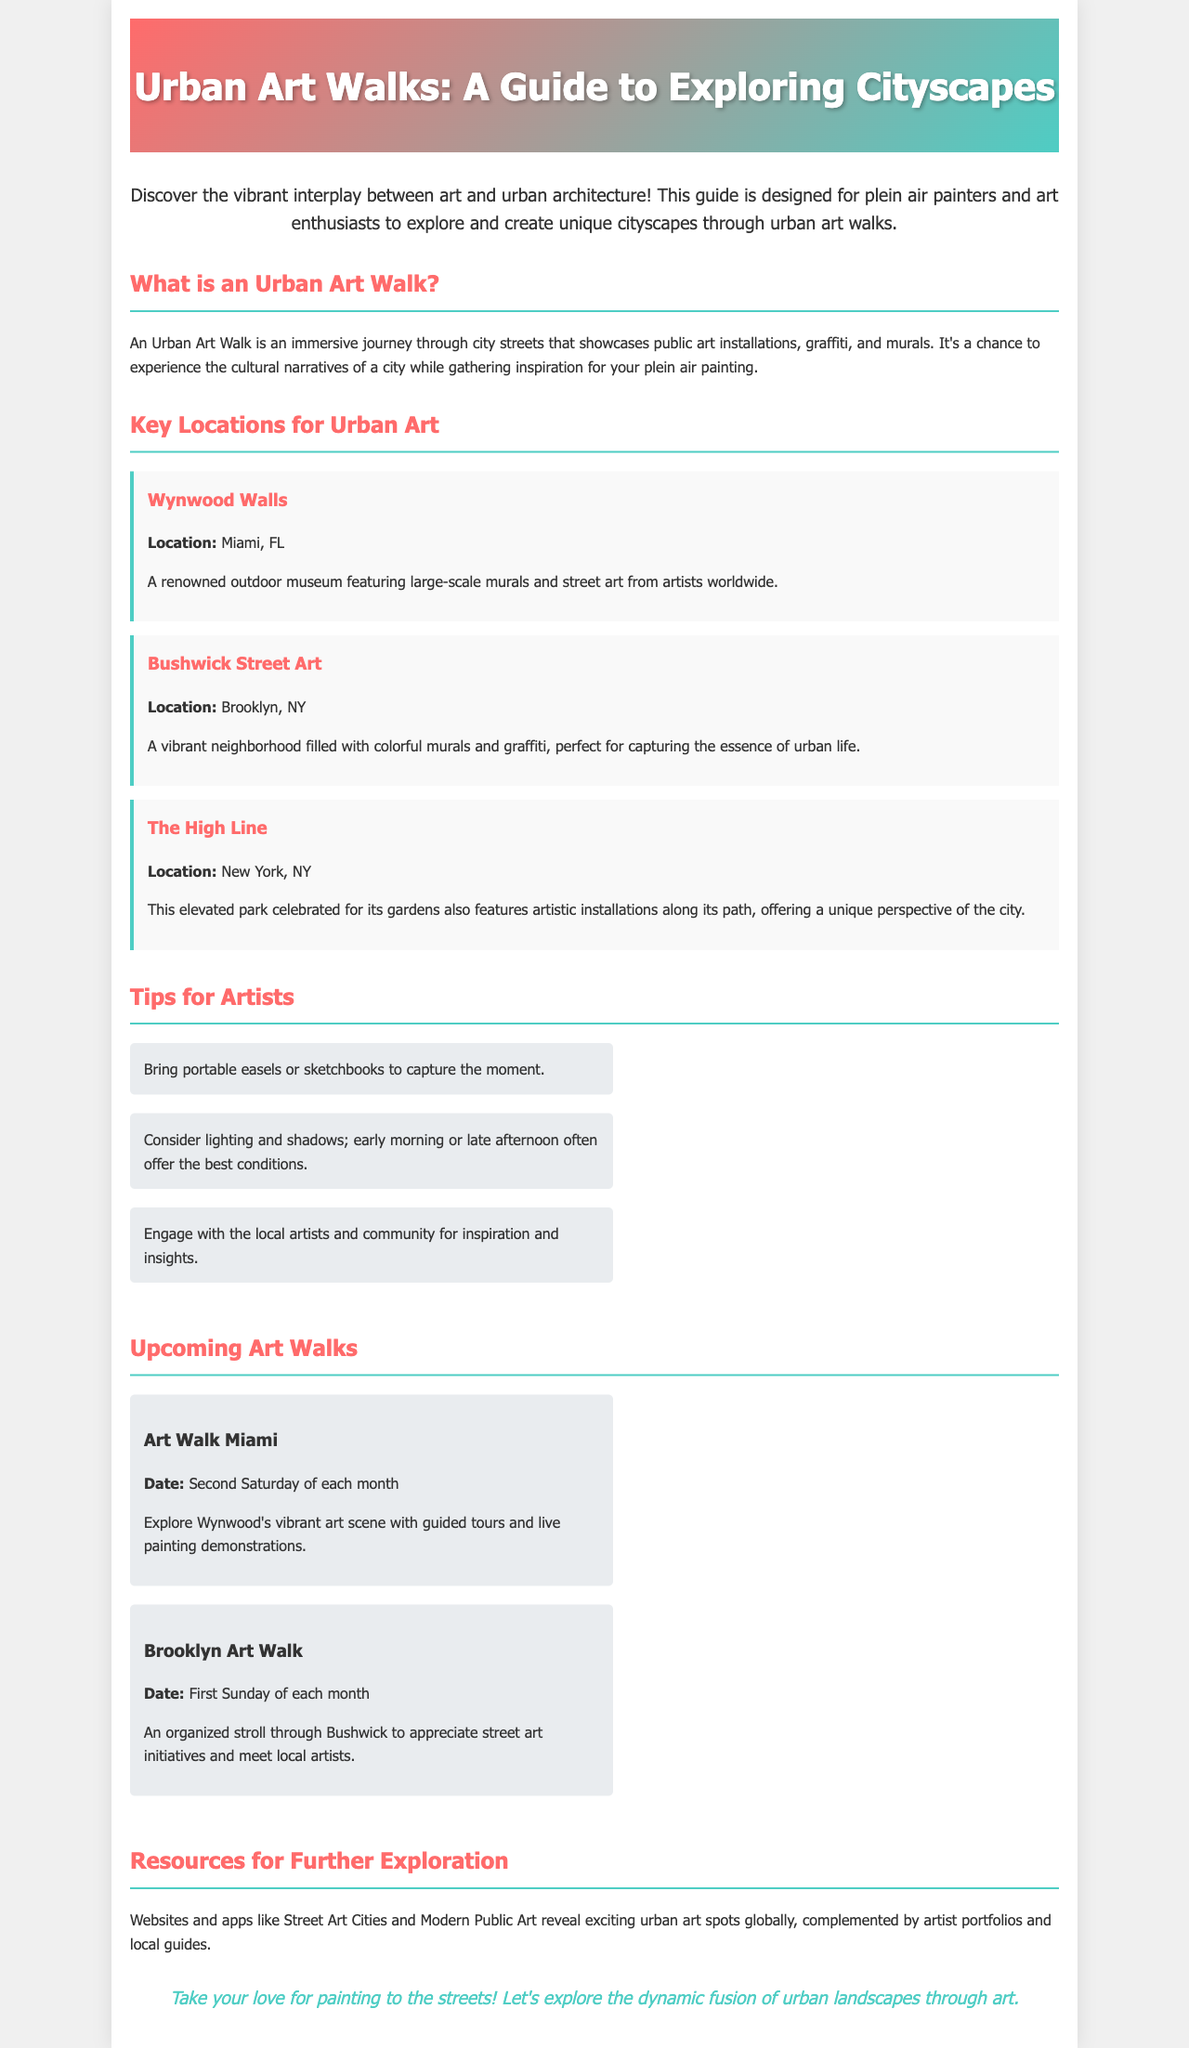What is an Urban Art Walk? An Urban Art Walk is defined in the brochure as an immersive journey through city streets that showcases public art installations, graffiti, and murals.
Answer: An immersive journey through city streets What is the location of Wynwood Walls? The brochure specifies that Wynwood Walls is located in Miami, FL.
Answer: Miami, FL When does the Brooklyn Art Walk occur? The document states that the Brooklyn Art Walk takes place on the first Sunday of each month.
Answer: First Sunday of each month What is a tip for artists mentioned in the brochure? The document provides several tips for artists, one of which is to bring portable easels or sketchbooks to capture the moment.
Answer: Bring portable easels or sketchbooks Which location features artistic installations along its path? The brochure mentions that The High Line features artistic installations along its path.
Answer: The High Line What event is held on the second Saturday of each month? According to the document, the event held on the second Saturday of each month is Art Walk Miami.
Answer: Art Walk Miami What type of resources can help to explore urban art spots globally? The document mentions websites and apps like Street Art Cities and Modern Public Art as resources for exploring urban art spots.
Answer: Street Art Cities and Modern Public Art What is encouraged for artists to do during the walks? The brochure encourages artists to engage with local artists and the community for inspiration and insights.
Answer: Engage with local artists and community 